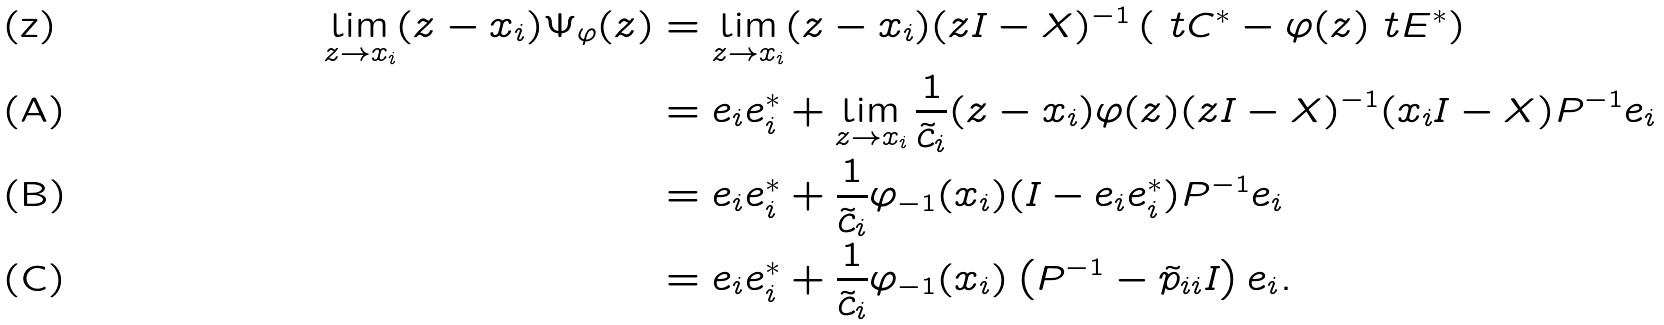Convert formula to latex. <formula><loc_0><loc_0><loc_500><loc_500>\lim _ { z \to x _ { i } } ( z - x _ { i } ) \Psi _ { \varphi } ( z ) & = \lim _ { z \to x _ { i } } ( z - x _ { i } ) ( z I - X ) ^ { - 1 } \left ( \ t C ^ { * } - \varphi ( z ) \ t E ^ { * } \right ) \\ & = e _ { i } e _ { i } ^ { * } + \lim _ { z \to x _ { i } } \frac { 1 } { \tilde { c } _ { i } } ( z - x _ { i } ) \varphi ( z ) ( z I - X ) ^ { - 1 } ( x _ { i } I - X ) P ^ { - 1 } e _ { i } \\ & = e _ { i } e _ { i } ^ { * } + \frac { 1 } { \tilde { c } _ { i } } \varphi _ { - 1 } ( x _ { i } ) ( I - e _ { i } e _ { i } ^ { * } ) P ^ { - 1 } e _ { i } \\ & = e _ { i } e _ { i } ^ { * } + \frac { 1 } { \tilde { c } _ { i } } \varphi _ { - 1 } ( x _ { i } ) \left ( P ^ { - 1 } - \tilde { p } _ { i i } I \right ) e _ { i } .</formula> 